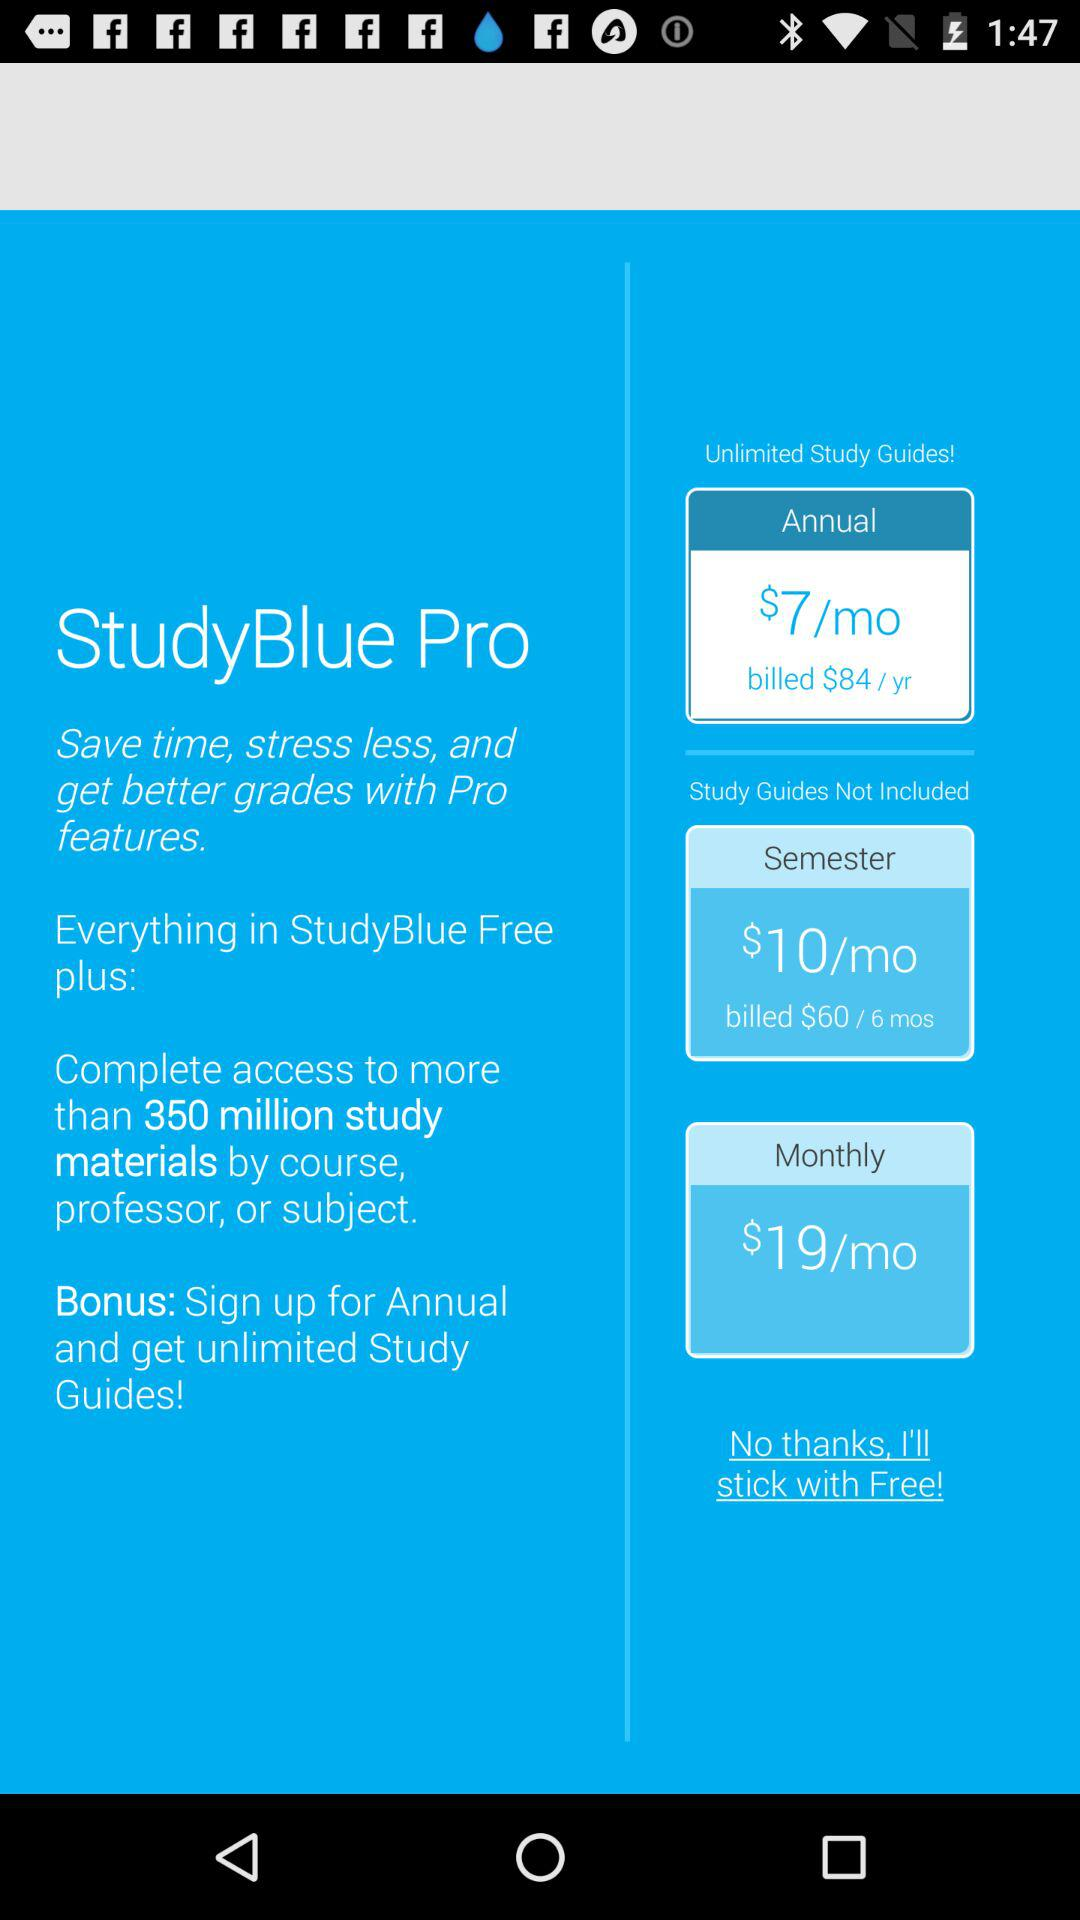How many more months of study materials do you get with the annual subscription than the semester subscription?
Answer the question using a single word or phrase. 6 